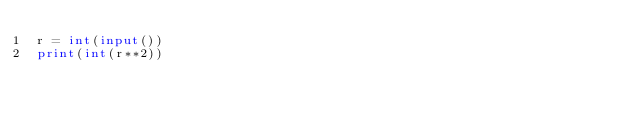Convert code to text. <code><loc_0><loc_0><loc_500><loc_500><_Python_>r = int(input())
print(int(r**2))</code> 